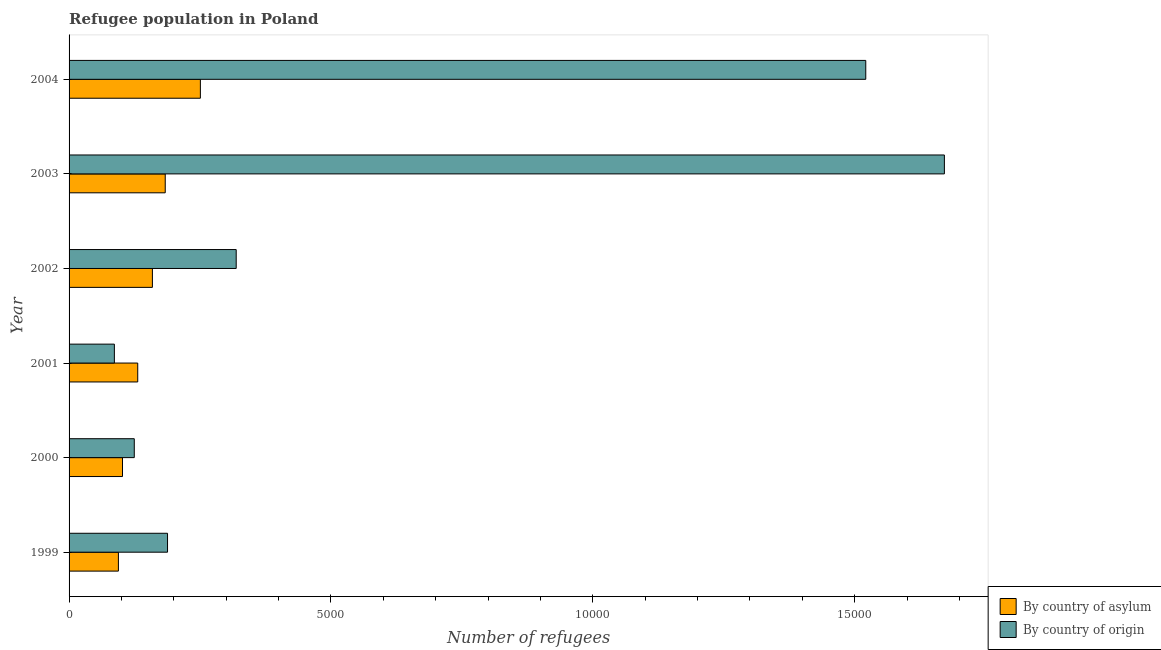How many different coloured bars are there?
Ensure brevity in your answer.  2. How many groups of bars are there?
Your answer should be compact. 6. Are the number of bars on each tick of the Y-axis equal?
Keep it short and to the point. Yes. How many bars are there on the 3rd tick from the bottom?
Offer a very short reply. 2. In how many cases, is the number of bars for a given year not equal to the number of legend labels?
Offer a very short reply. 0. What is the number of refugees by country of asylum in 2003?
Your answer should be compact. 1836. Across all years, what is the maximum number of refugees by country of asylum?
Keep it short and to the point. 2507. Across all years, what is the minimum number of refugees by country of asylum?
Provide a succinct answer. 942. In which year was the number of refugees by country of origin minimum?
Keep it short and to the point. 2001. What is the total number of refugees by country of origin in the graph?
Provide a short and direct response. 3.91e+04. What is the difference between the number of refugees by country of origin in 2003 and that in 2004?
Your answer should be very brief. 1501. What is the difference between the number of refugees by country of asylum in 2003 and the number of refugees by country of origin in 2004?
Offer a very short reply. -1.34e+04. What is the average number of refugees by country of asylum per year?
Provide a succinct answer. 1534.5. In the year 2004, what is the difference between the number of refugees by country of asylum and number of refugees by country of origin?
Keep it short and to the point. -1.27e+04. What is the ratio of the number of refugees by country of origin in 2002 to that in 2003?
Provide a short and direct response. 0.19. What is the difference between the highest and the second highest number of refugees by country of origin?
Your answer should be very brief. 1501. What is the difference between the highest and the lowest number of refugees by country of asylum?
Your answer should be compact. 1565. What does the 2nd bar from the top in 2001 represents?
Provide a succinct answer. By country of asylum. What does the 2nd bar from the bottom in 2002 represents?
Your answer should be very brief. By country of origin. How many bars are there?
Give a very brief answer. 12. What is the difference between two consecutive major ticks on the X-axis?
Your response must be concise. 5000. Does the graph contain any zero values?
Keep it short and to the point. No. Does the graph contain grids?
Offer a very short reply. No. Where does the legend appear in the graph?
Provide a short and direct response. Bottom right. What is the title of the graph?
Your answer should be compact. Refugee population in Poland. What is the label or title of the X-axis?
Your answer should be very brief. Number of refugees. What is the label or title of the Y-axis?
Ensure brevity in your answer.  Year. What is the Number of refugees in By country of asylum in 1999?
Provide a short and direct response. 942. What is the Number of refugees of By country of origin in 1999?
Your answer should be compact. 1880. What is the Number of refugees of By country of asylum in 2000?
Your answer should be very brief. 1020. What is the Number of refugees of By country of origin in 2000?
Ensure brevity in your answer.  1245. What is the Number of refugees in By country of asylum in 2001?
Your answer should be very brief. 1311. What is the Number of refugees of By country of origin in 2001?
Your answer should be compact. 865. What is the Number of refugees in By country of asylum in 2002?
Make the answer very short. 1591. What is the Number of refugees in By country of origin in 2002?
Ensure brevity in your answer.  3191. What is the Number of refugees in By country of asylum in 2003?
Your response must be concise. 1836. What is the Number of refugees in By country of origin in 2003?
Your response must be concise. 1.67e+04. What is the Number of refugees of By country of asylum in 2004?
Provide a short and direct response. 2507. What is the Number of refugees in By country of origin in 2004?
Provide a short and direct response. 1.52e+04. Across all years, what is the maximum Number of refugees in By country of asylum?
Your answer should be compact. 2507. Across all years, what is the maximum Number of refugees in By country of origin?
Ensure brevity in your answer.  1.67e+04. Across all years, what is the minimum Number of refugees in By country of asylum?
Offer a very short reply. 942. Across all years, what is the minimum Number of refugees in By country of origin?
Make the answer very short. 865. What is the total Number of refugees of By country of asylum in the graph?
Provide a short and direct response. 9207. What is the total Number of refugees in By country of origin in the graph?
Your response must be concise. 3.91e+04. What is the difference between the Number of refugees in By country of asylum in 1999 and that in 2000?
Ensure brevity in your answer.  -78. What is the difference between the Number of refugees of By country of origin in 1999 and that in 2000?
Keep it short and to the point. 635. What is the difference between the Number of refugees in By country of asylum in 1999 and that in 2001?
Keep it short and to the point. -369. What is the difference between the Number of refugees of By country of origin in 1999 and that in 2001?
Your answer should be compact. 1015. What is the difference between the Number of refugees of By country of asylum in 1999 and that in 2002?
Keep it short and to the point. -649. What is the difference between the Number of refugees in By country of origin in 1999 and that in 2002?
Your response must be concise. -1311. What is the difference between the Number of refugees in By country of asylum in 1999 and that in 2003?
Make the answer very short. -894. What is the difference between the Number of refugees of By country of origin in 1999 and that in 2003?
Your answer should be very brief. -1.48e+04. What is the difference between the Number of refugees of By country of asylum in 1999 and that in 2004?
Your answer should be very brief. -1565. What is the difference between the Number of refugees of By country of origin in 1999 and that in 2004?
Offer a very short reply. -1.33e+04. What is the difference between the Number of refugees of By country of asylum in 2000 and that in 2001?
Your answer should be very brief. -291. What is the difference between the Number of refugees in By country of origin in 2000 and that in 2001?
Your answer should be very brief. 380. What is the difference between the Number of refugees of By country of asylum in 2000 and that in 2002?
Offer a terse response. -571. What is the difference between the Number of refugees in By country of origin in 2000 and that in 2002?
Keep it short and to the point. -1946. What is the difference between the Number of refugees in By country of asylum in 2000 and that in 2003?
Ensure brevity in your answer.  -816. What is the difference between the Number of refugees of By country of origin in 2000 and that in 2003?
Offer a very short reply. -1.55e+04. What is the difference between the Number of refugees in By country of asylum in 2000 and that in 2004?
Keep it short and to the point. -1487. What is the difference between the Number of refugees of By country of origin in 2000 and that in 2004?
Your answer should be very brief. -1.40e+04. What is the difference between the Number of refugees in By country of asylum in 2001 and that in 2002?
Offer a terse response. -280. What is the difference between the Number of refugees of By country of origin in 2001 and that in 2002?
Offer a terse response. -2326. What is the difference between the Number of refugees in By country of asylum in 2001 and that in 2003?
Your answer should be very brief. -525. What is the difference between the Number of refugees in By country of origin in 2001 and that in 2003?
Offer a very short reply. -1.58e+04. What is the difference between the Number of refugees in By country of asylum in 2001 and that in 2004?
Your answer should be compact. -1196. What is the difference between the Number of refugees in By country of origin in 2001 and that in 2004?
Give a very brief answer. -1.43e+04. What is the difference between the Number of refugees of By country of asylum in 2002 and that in 2003?
Offer a very short reply. -245. What is the difference between the Number of refugees in By country of origin in 2002 and that in 2003?
Make the answer very short. -1.35e+04. What is the difference between the Number of refugees in By country of asylum in 2002 and that in 2004?
Give a very brief answer. -916. What is the difference between the Number of refugees in By country of origin in 2002 and that in 2004?
Provide a short and direct response. -1.20e+04. What is the difference between the Number of refugees of By country of asylum in 2003 and that in 2004?
Offer a very short reply. -671. What is the difference between the Number of refugees in By country of origin in 2003 and that in 2004?
Your response must be concise. 1501. What is the difference between the Number of refugees in By country of asylum in 1999 and the Number of refugees in By country of origin in 2000?
Offer a very short reply. -303. What is the difference between the Number of refugees in By country of asylum in 1999 and the Number of refugees in By country of origin in 2002?
Provide a succinct answer. -2249. What is the difference between the Number of refugees of By country of asylum in 1999 and the Number of refugees of By country of origin in 2003?
Provide a succinct answer. -1.58e+04. What is the difference between the Number of refugees in By country of asylum in 1999 and the Number of refugees in By country of origin in 2004?
Give a very brief answer. -1.43e+04. What is the difference between the Number of refugees in By country of asylum in 2000 and the Number of refugees in By country of origin in 2001?
Offer a very short reply. 155. What is the difference between the Number of refugees in By country of asylum in 2000 and the Number of refugees in By country of origin in 2002?
Your answer should be very brief. -2171. What is the difference between the Number of refugees of By country of asylum in 2000 and the Number of refugees of By country of origin in 2003?
Give a very brief answer. -1.57e+04. What is the difference between the Number of refugees of By country of asylum in 2000 and the Number of refugees of By country of origin in 2004?
Your response must be concise. -1.42e+04. What is the difference between the Number of refugees in By country of asylum in 2001 and the Number of refugees in By country of origin in 2002?
Offer a very short reply. -1880. What is the difference between the Number of refugees in By country of asylum in 2001 and the Number of refugees in By country of origin in 2003?
Offer a terse response. -1.54e+04. What is the difference between the Number of refugees of By country of asylum in 2001 and the Number of refugees of By country of origin in 2004?
Your answer should be compact. -1.39e+04. What is the difference between the Number of refugees of By country of asylum in 2002 and the Number of refugees of By country of origin in 2003?
Your response must be concise. -1.51e+04. What is the difference between the Number of refugees of By country of asylum in 2002 and the Number of refugees of By country of origin in 2004?
Your answer should be very brief. -1.36e+04. What is the difference between the Number of refugees of By country of asylum in 2003 and the Number of refugees of By country of origin in 2004?
Your answer should be very brief. -1.34e+04. What is the average Number of refugees of By country of asylum per year?
Ensure brevity in your answer.  1534.5. What is the average Number of refugees of By country of origin per year?
Provide a short and direct response. 6517.33. In the year 1999, what is the difference between the Number of refugees of By country of asylum and Number of refugees of By country of origin?
Give a very brief answer. -938. In the year 2000, what is the difference between the Number of refugees of By country of asylum and Number of refugees of By country of origin?
Your response must be concise. -225. In the year 2001, what is the difference between the Number of refugees in By country of asylum and Number of refugees in By country of origin?
Your answer should be compact. 446. In the year 2002, what is the difference between the Number of refugees of By country of asylum and Number of refugees of By country of origin?
Offer a terse response. -1600. In the year 2003, what is the difference between the Number of refugees in By country of asylum and Number of refugees in By country of origin?
Provide a short and direct response. -1.49e+04. In the year 2004, what is the difference between the Number of refugees in By country of asylum and Number of refugees in By country of origin?
Make the answer very short. -1.27e+04. What is the ratio of the Number of refugees of By country of asylum in 1999 to that in 2000?
Your answer should be very brief. 0.92. What is the ratio of the Number of refugees in By country of origin in 1999 to that in 2000?
Provide a short and direct response. 1.51. What is the ratio of the Number of refugees of By country of asylum in 1999 to that in 2001?
Offer a very short reply. 0.72. What is the ratio of the Number of refugees in By country of origin in 1999 to that in 2001?
Offer a terse response. 2.17. What is the ratio of the Number of refugees of By country of asylum in 1999 to that in 2002?
Ensure brevity in your answer.  0.59. What is the ratio of the Number of refugees of By country of origin in 1999 to that in 2002?
Offer a terse response. 0.59. What is the ratio of the Number of refugees in By country of asylum in 1999 to that in 2003?
Keep it short and to the point. 0.51. What is the ratio of the Number of refugees of By country of origin in 1999 to that in 2003?
Ensure brevity in your answer.  0.11. What is the ratio of the Number of refugees of By country of asylum in 1999 to that in 2004?
Give a very brief answer. 0.38. What is the ratio of the Number of refugees in By country of origin in 1999 to that in 2004?
Make the answer very short. 0.12. What is the ratio of the Number of refugees of By country of asylum in 2000 to that in 2001?
Provide a succinct answer. 0.78. What is the ratio of the Number of refugees in By country of origin in 2000 to that in 2001?
Provide a short and direct response. 1.44. What is the ratio of the Number of refugees of By country of asylum in 2000 to that in 2002?
Your answer should be very brief. 0.64. What is the ratio of the Number of refugees in By country of origin in 2000 to that in 2002?
Your answer should be very brief. 0.39. What is the ratio of the Number of refugees in By country of asylum in 2000 to that in 2003?
Your answer should be compact. 0.56. What is the ratio of the Number of refugees of By country of origin in 2000 to that in 2003?
Your answer should be very brief. 0.07. What is the ratio of the Number of refugees of By country of asylum in 2000 to that in 2004?
Your answer should be very brief. 0.41. What is the ratio of the Number of refugees in By country of origin in 2000 to that in 2004?
Ensure brevity in your answer.  0.08. What is the ratio of the Number of refugees in By country of asylum in 2001 to that in 2002?
Provide a succinct answer. 0.82. What is the ratio of the Number of refugees of By country of origin in 2001 to that in 2002?
Provide a succinct answer. 0.27. What is the ratio of the Number of refugees in By country of asylum in 2001 to that in 2003?
Your answer should be very brief. 0.71. What is the ratio of the Number of refugees of By country of origin in 2001 to that in 2003?
Keep it short and to the point. 0.05. What is the ratio of the Number of refugees of By country of asylum in 2001 to that in 2004?
Ensure brevity in your answer.  0.52. What is the ratio of the Number of refugees of By country of origin in 2001 to that in 2004?
Give a very brief answer. 0.06. What is the ratio of the Number of refugees of By country of asylum in 2002 to that in 2003?
Your answer should be very brief. 0.87. What is the ratio of the Number of refugees in By country of origin in 2002 to that in 2003?
Your answer should be very brief. 0.19. What is the ratio of the Number of refugees of By country of asylum in 2002 to that in 2004?
Provide a short and direct response. 0.63. What is the ratio of the Number of refugees of By country of origin in 2002 to that in 2004?
Offer a very short reply. 0.21. What is the ratio of the Number of refugees of By country of asylum in 2003 to that in 2004?
Provide a succinct answer. 0.73. What is the ratio of the Number of refugees in By country of origin in 2003 to that in 2004?
Offer a very short reply. 1.1. What is the difference between the highest and the second highest Number of refugees of By country of asylum?
Offer a very short reply. 671. What is the difference between the highest and the second highest Number of refugees of By country of origin?
Provide a short and direct response. 1501. What is the difference between the highest and the lowest Number of refugees in By country of asylum?
Provide a succinct answer. 1565. What is the difference between the highest and the lowest Number of refugees of By country of origin?
Your answer should be compact. 1.58e+04. 